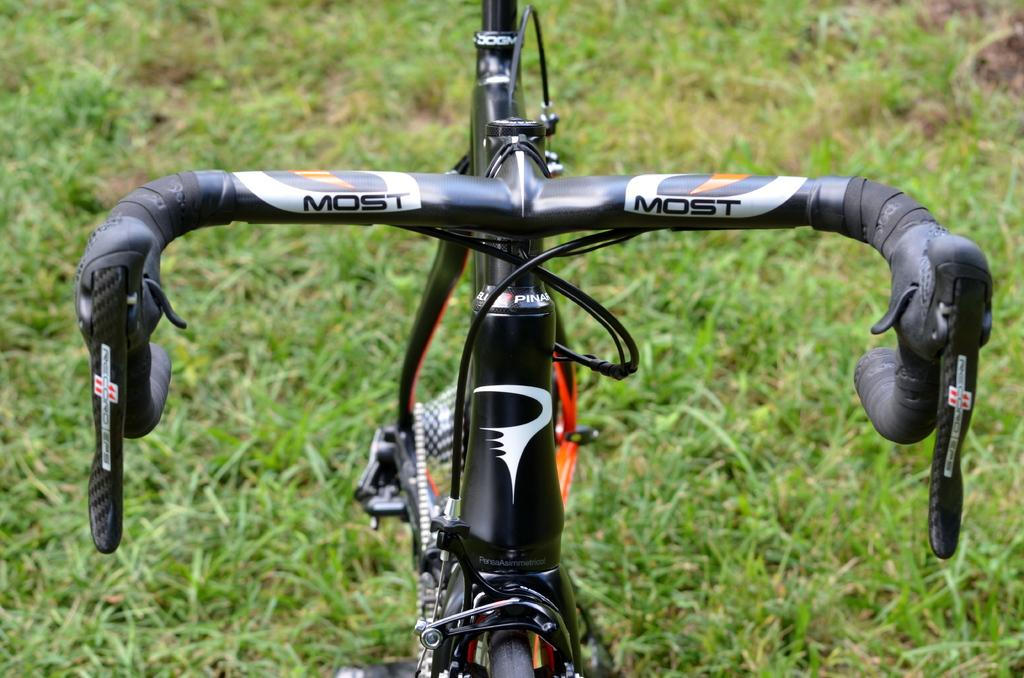What is the main object in the image? There is a cycle in the image. What color is the cycle? The cycle is black in color. What type of vegetation is visible at the bottom of the image? There is green grass at the bottom of the image. What type of furniture is visible in the image? There is no furniture present in the image; it features a black cycle and green grass. How many people are wearing underwear in the image? There are no people visible in the image, so it is impossible to determine how many might be wearing underwear. 